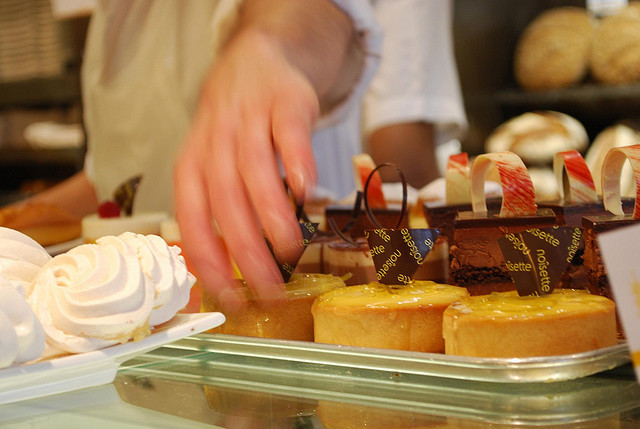<image>What entree is this? It is ambiguous what the entree is. It appears to be a dessert. What entree is this? I am not sure what entree is this. It can be seen as flan, cupcakes, breakfast, or dessert. 